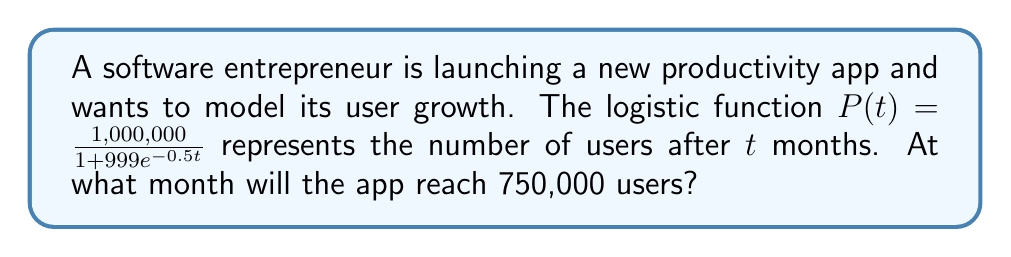Provide a solution to this math problem. To solve this problem, we'll follow these steps:

1) We need to find $t$ when $P(t) = 750,000$. Let's set up the equation:

   $750,000 = \frac{1,000,000}{1 + 999e^{-0.5t}}$

2) Multiply both sides by the denominator:

   $750,000(1 + 999e^{-0.5t}) = 1,000,000$

3) Distribute on the left side:

   $750,000 + 749,250,000e^{-0.5t} = 1,000,000$

4) Subtract 750,000 from both sides:

   $749,250,000e^{-0.5t} = 250,000$

5) Divide both sides by 749,250,000:

   $e^{-0.5t} = \frac{1}{2,997}$

6) Take the natural log of both sides:

   $-0.5t = \ln(\frac{1}{2,997})$

7) Divide both sides by -0.5:

   $t = -\frac{2}{0.5}\ln(\frac{1}{2,997}) = 2\ln(2,997) \approx 16.12$

8) Since we're dealing with months, we round up to the nearest whole number.
Answer: 17 months 